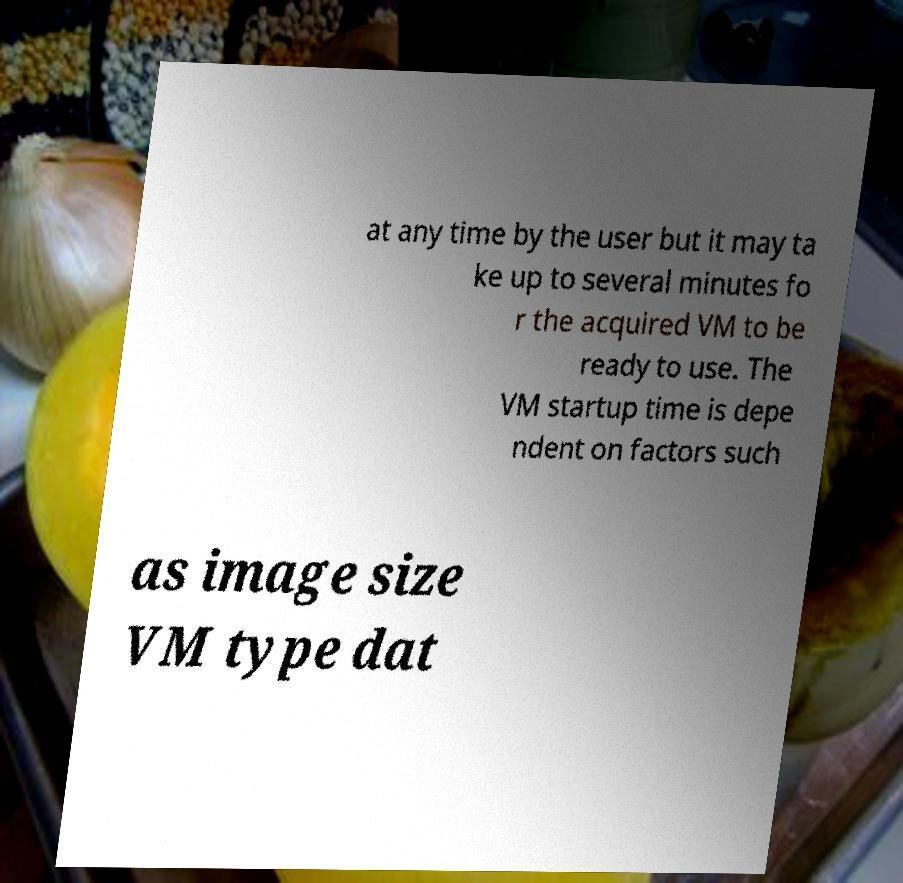Could you extract and type out the text from this image? at any time by the user but it may ta ke up to several minutes fo r the acquired VM to be ready to use. The VM startup time is depe ndent on factors such as image size VM type dat 